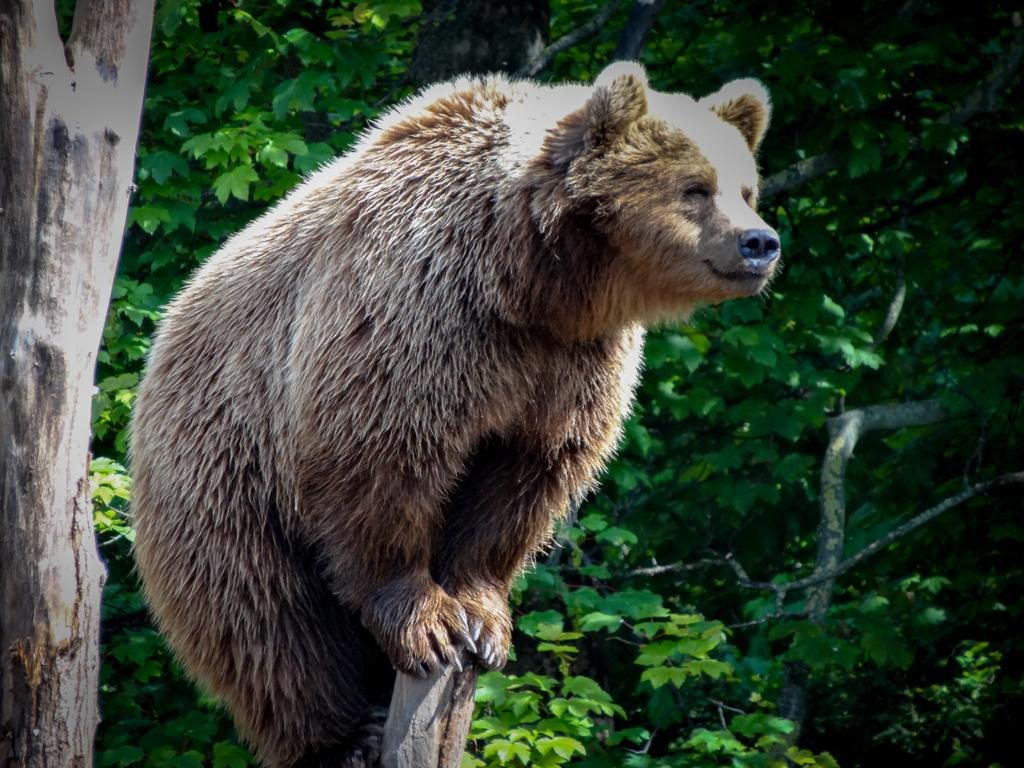What is the person in the image doing? The person is standing on a wooden stick in the image. What can be seen in the background of the image? There are trees and plants in the background of the image. What type of riddle is the person solving in the image? There is no riddle present in the image; the person is simply standing on a wooden stick. What part of the person's body is being used as fuel to maintain their balance on the wooden stick? The person's body is not being used as fuel in the image; they are simply standing on a wooden stick. 